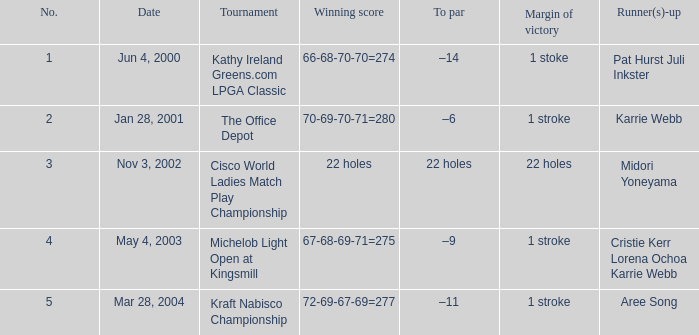What is the to par dated may 4, 2003? –9. 